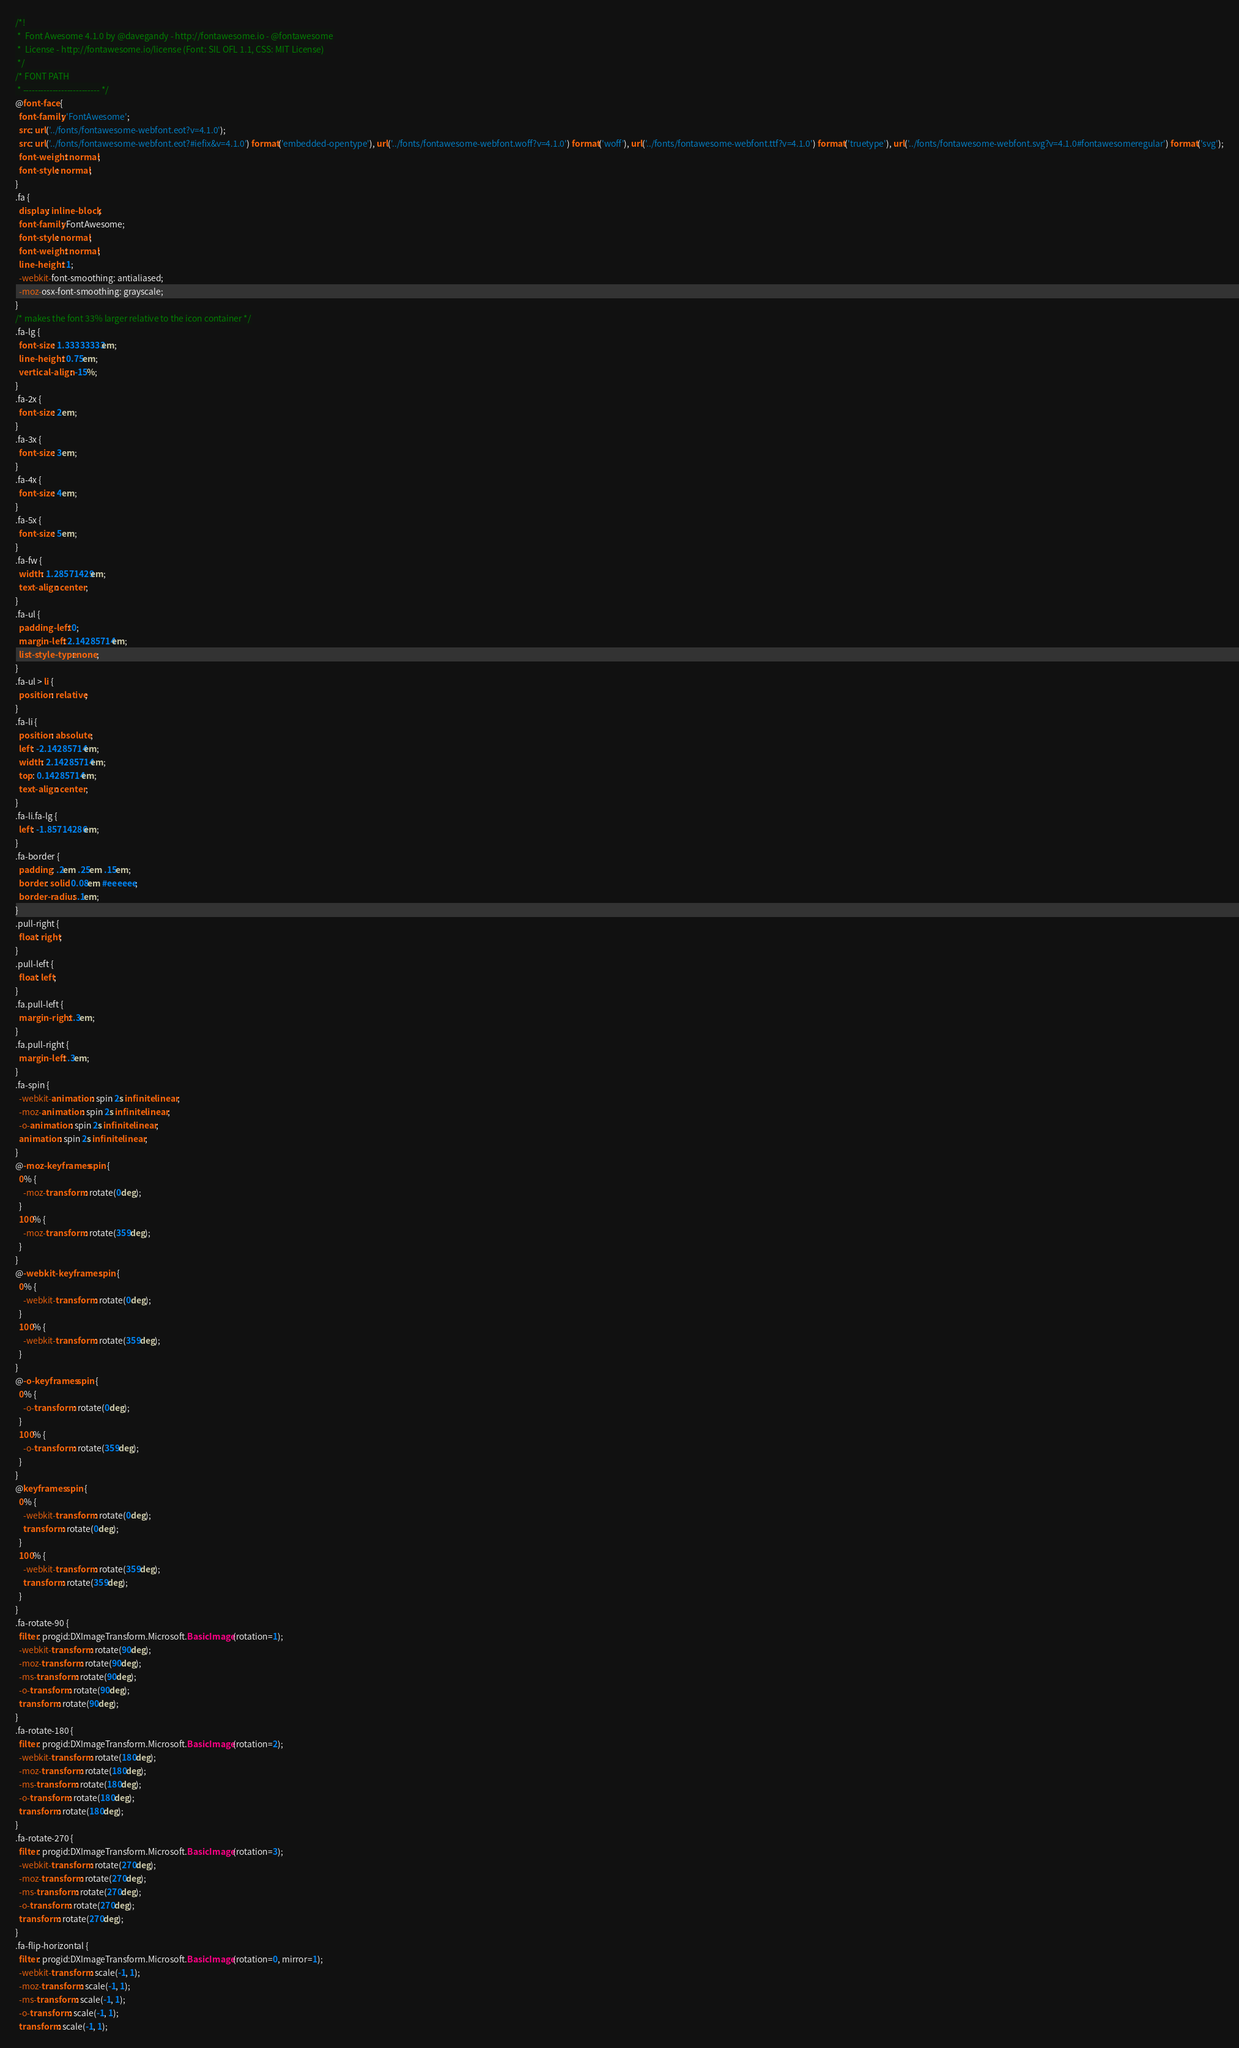Convert code to text. <code><loc_0><loc_0><loc_500><loc_500><_CSS_>/*!
 *  Font Awesome 4.1.0 by @davegandy - http://fontawesome.io - @fontawesome
 *  License - http://fontawesome.io/license (Font: SIL OFL 1.1, CSS: MIT License)
 */
/* FONT PATH
 * -------------------------- */
@font-face {
  font-family: 'FontAwesome';
  src: url('../fonts/fontawesome-webfont.eot?v=4.1.0');
  src: url('../fonts/fontawesome-webfont.eot?#iefix&v=4.1.0') format('embedded-opentype'), url('../fonts/fontawesome-webfont.woff?v=4.1.0') format('woff'), url('../fonts/fontawesome-webfont.ttf?v=4.1.0') format('truetype'), url('../fonts/fontawesome-webfont.svg?v=4.1.0#fontawesomeregular') format('svg');
  font-weight: normal;
  font-style: normal;
}
.fa {
  display: inline-block;
  font-family: FontAwesome;
  font-style: normal;
  font-weight: normal;
  line-height: 1;
  -webkit-font-smoothing: antialiased;
  -moz-osx-font-smoothing: grayscale;
}
/* makes the font 33% larger relative to the icon container */
.fa-lg {
  font-size: 1.33333333em;
  line-height: 0.75em;
  vertical-align: -15%;
}
.fa-2x {
  font-size: 2em;
}
.fa-3x {
  font-size: 3em;
}
.fa-4x {
  font-size: 4em;
}
.fa-5x {
  font-size: 5em;
}
.fa-fw {
  width: 1.28571429em;
  text-align: center;
}
.fa-ul {
  padding-left: 0;
  margin-left: 2.14285714em;
  list-style-type: none;
}
.fa-ul > li {
  position: relative;
}
.fa-li {
  position: absolute;
  left: -2.14285714em;
  width: 2.14285714em;
  top: 0.14285714em;
  text-align: center;
}
.fa-li.fa-lg {
  left: -1.85714286em;
}
.fa-border {
  padding: .2em .25em .15em;
  border: solid 0.08em #eeeeee;
  border-radius: .1em;
}
.pull-right {
  float: right;
}
.pull-left {
  float: left;
}
.fa.pull-left {
  margin-right: .3em;
}
.fa.pull-right {
  margin-left: .3em;
}
.fa-spin {
  -webkit-animation: spin 2s infinite linear;
  -moz-animation: spin 2s infinite linear;
  -o-animation: spin 2s infinite linear;
  animation: spin 2s infinite linear;
}
@-moz-keyframes spin {
  0% {
    -moz-transform: rotate(0deg);
  }
  100% {
    -moz-transform: rotate(359deg);
  }
}
@-webkit-keyframes spin {
  0% {
    -webkit-transform: rotate(0deg);
  }
  100% {
    -webkit-transform: rotate(359deg);
  }
}
@-o-keyframes spin {
  0% {
    -o-transform: rotate(0deg);
  }
  100% {
    -o-transform: rotate(359deg);
  }
}
@keyframes spin {
  0% {
    -webkit-transform: rotate(0deg);
    transform: rotate(0deg);
  }
  100% {
    -webkit-transform: rotate(359deg);
    transform: rotate(359deg);
  }
}
.fa-rotate-90 {
  filter: progid:DXImageTransform.Microsoft.BasicImage(rotation=1);
  -webkit-transform: rotate(90deg);
  -moz-transform: rotate(90deg);
  -ms-transform: rotate(90deg);
  -o-transform: rotate(90deg);
  transform: rotate(90deg);
}
.fa-rotate-180 {
  filter: progid:DXImageTransform.Microsoft.BasicImage(rotation=2);
  -webkit-transform: rotate(180deg);
  -moz-transform: rotate(180deg);
  -ms-transform: rotate(180deg);
  -o-transform: rotate(180deg);
  transform: rotate(180deg);
}
.fa-rotate-270 {
  filter: progid:DXImageTransform.Microsoft.BasicImage(rotation=3);
  -webkit-transform: rotate(270deg);
  -moz-transform: rotate(270deg);
  -ms-transform: rotate(270deg);
  -o-transform: rotate(270deg);
  transform: rotate(270deg);
}
.fa-flip-horizontal {
  filter: progid:DXImageTransform.Microsoft.BasicImage(rotation=0, mirror=1);
  -webkit-transform: scale(-1, 1);
  -moz-transform: scale(-1, 1);
  -ms-transform: scale(-1, 1);
  -o-transform: scale(-1, 1);
  transform: scale(-1, 1);</code> 